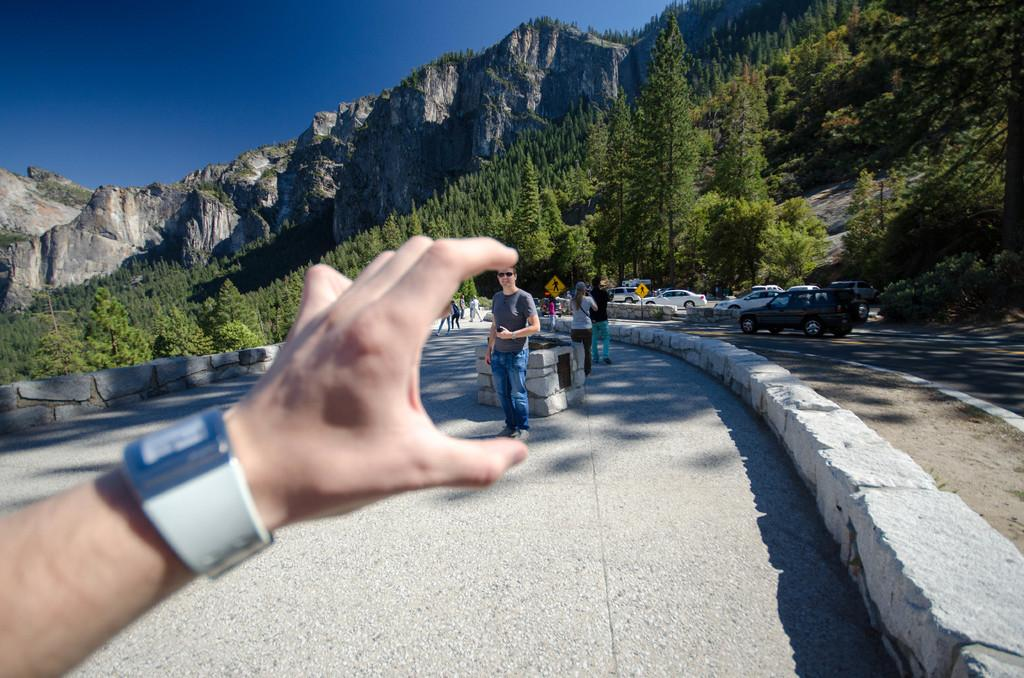What is the main subject in the foreground of the image? There is a hand with a watch in the foreground of the image. What can be seen in the background of the image? There are many people, cars on the road, hills, and trees in the background of the image. How is the sky depicted in the image? The sky is clear in the image. What type of treatment is the secretary providing in the image? There is no secretary present in the image, so no treatment can be observed. How far away are the hills from the hand with the watch in the image? The distance between the hand with the watch and the hills cannot be determined from the image. 